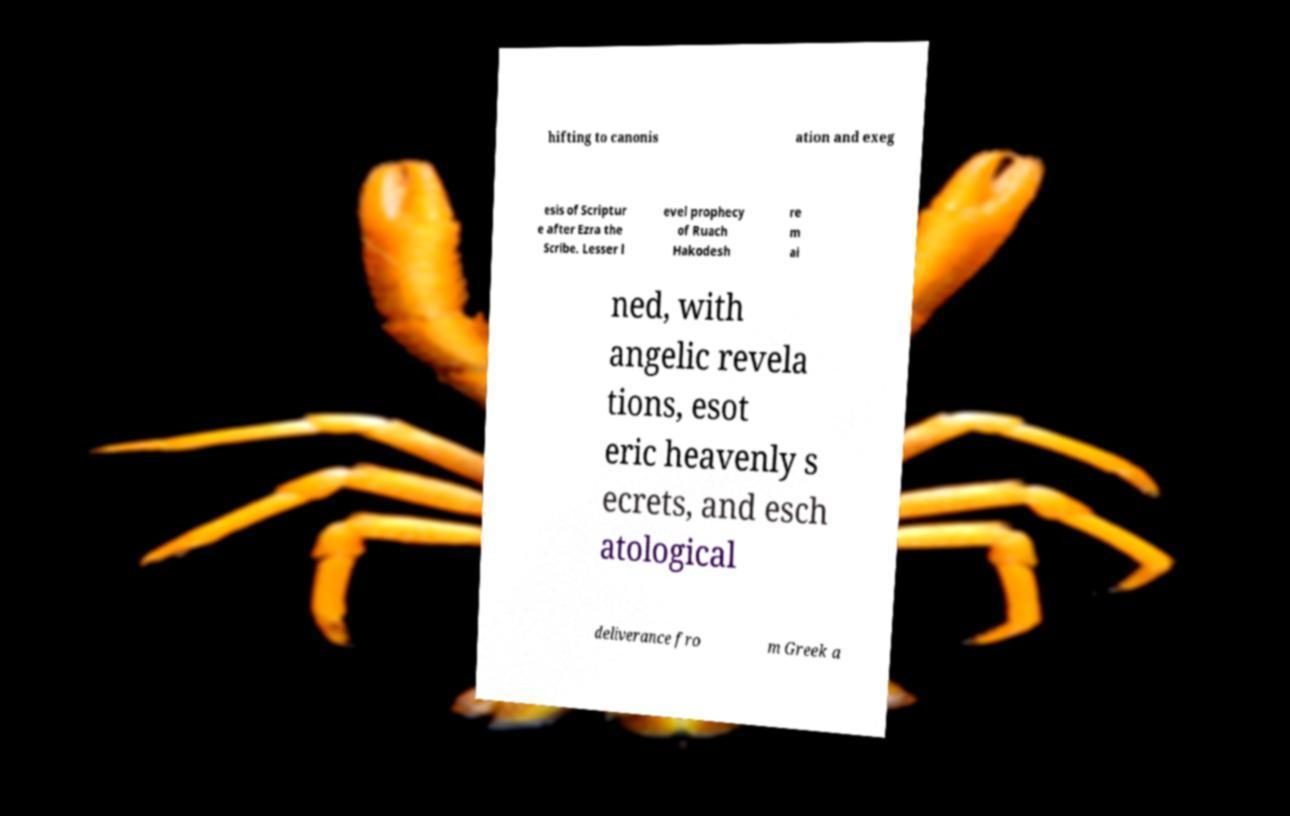What messages or text are displayed in this image? I need them in a readable, typed format. hifting to canonis ation and exeg esis of Scriptur e after Ezra the Scribe. Lesser l evel prophecy of Ruach Hakodesh re m ai ned, with angelic revela tions, esot eric heavenly s ecrets, and esch atological deliverance fro m Greek a 